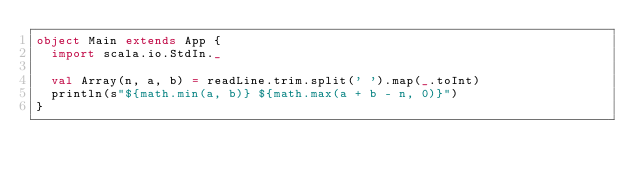<code> <loc_0><loc_0><loc_500><loc_500><_Scala_>object Main extends App {
  import scala.io.StdIn._

  val Array(n, a, b) = readLine.trim.split(' ').map(_.toInt)
  println(s"${math.min(a, b)} ${math.max(a + b - n, 0)}")
}</code> 